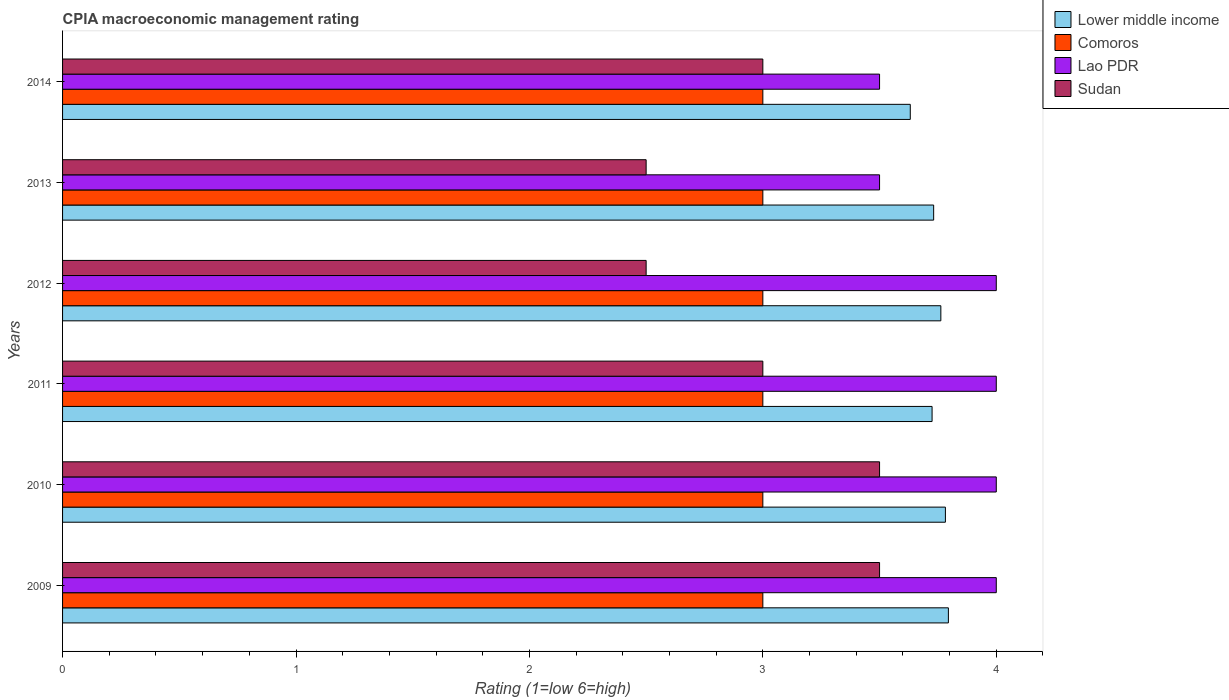How many groups of bars are there?
Make the answer very short. 6. How many bars are there on the 2nd tick from the top?
Keep it short and to the point. 4. How many bars are there on the 3rd tick from the bottom?
Ensure brevity in your answer.  4. What is the label of the 4th group of bars from the top?
Ensure brevity in your answer.  2011. What is the CPIA rating in Lower middle income in 2009?
Make the answer very short. 3.79. Across all years, what is the maximum CPIA rating in Lao PDR?
Offer a terse response. 4. Across all years, what is the minimum CPIA rating in Lower middle income?
Offer a very short reply. 3.63. In which year was the CPIA rating in Lao PDR minimum?
Keep it short and to the point. 2013. What is the difference between the CPIA rating in Lao PDR in 2012 and that in 2013?
Keep it short and to the point. 0.5. What is the difference between the CPIA rating in Comoros in 2013 and the CPIA rating in Lower middle income in 2012?
Your answer should be very brief. -0.76. What is the average CPIA rating in Lao PDR per year?
Give a very brief answer. 3.83. In the year 2013, what is the difference between the CPIA rating in Lao PDR and CPIA rating in Lower middle income?
Your answer should be very brief. -0.23. What is the ratio of the CPIA rating in Lao PDR in 2012 to that in 2014?
Keep it short and to the point. 1.14. Is the CPIA rating in Lower middle income in 2010 less than that in 2013?
Offer a very short reply. No. Is the difference between the CPIA rating in Lao PDR in 2009 and 2012 greater than the difference between the CPIA rating in Lower middle income in 2009 and 2012?
Make the answer very short. No. What is the difference between the highest and the second highest CPIA rating in Lower middle income?
Ensure brevity in your answer.  0.01. In how many years, is the CPIA rating in Sudan greater than the average CPIA rating in Sudan taken over all years?
Give a very brief answer. 2. What does the 1st bar from the top in 2013 represents?
Your response must be concise. Sudan. What does the 1st bar from the bottom in 2011 represents?
Ensure brevity in your answer.  Lower middle income. How many years are there in the graph?
Your answer should be very brief. 6. What is the difference between two consecutive major ticks on the X-axis?
Provide a succinct answer. 1. Are the values on the major ticks of X-axis written in scientific E-notation?
Keep it short and to the point. No. How many legend labels are there?
Your answer should be compact. 4. How are the legend labels stacked?
Offer a terse response. Vertical. What is the title of the graph?
Provide a succinct answer. CPIA macroeconomic management rating. Does "Trinidad and Tobago" appear as one of the legend labels in the graph?
Provide a succinct answer. No. What is the label or title of the X-axis?
Make the answer very short. Rating (1=low 6=high). What is the Rating (1=low 6=high) in Lower middle income in 2009?
Keep it short and to the point. 3.79. What is the Rating (1=low 6=high) in Comoros in 2009?
Make the answer very short. 3. What is the Rating (1=low 6=high) of Lao PDR in 2009?
Your answer should be compact. 4. What is the Rating (1=low 6=high) of Sudan in 2009?
Keep it short and to the point. 3.5. What is the Rating (1=low 6=high) of Lower middle income in 2010?
Offer a terse response. 3.78. What is the Rating (1=low 6=high) in Comoros in 2010?
Offer a very short reply. 3. What is the Rating (1=low 6=high) in Lao PDR in 2010?
Ensure brevity in your answer.  4. What is the Rating (1=low 6=high) in Sudan in 2010?
Offer a terse response. 3.5. What is the Rating (1=low 6=high) of Lower middle income in 2011?
Your response must be concise. 3.73. What is the Rating (1=low 6=high) of Comoros in 2011?
Your answer should be compact. 3. What is the Rating (1=low 6=high) in Lao PDR in 2011?
Keep it short and to the point. 4. What is the Rating (1=low 6=high) of Lower middle income in 2012?
Offer a very short reply. 3.76. What is the Rating (1=low 6=high) in Sudan in 2012?
Keep it short and to the point. 2.5. What is the Rating (1=low 6=high) in Lower middle income in 2013?
Your answer should be compact. 3.73. What is the Rating (1=low 6=high) in Comoros in 2013?
Provide a short and direct response. 3. What is the Rating (1=low 6=high) of Sudan in 2013?
Offer a very short reply. 2.5. What is the Rating (1=low 6=high) in Lower middle income in 2014?
Your answer should be very brief. 3.63. What is the Rating (1=low 6=high) in Lao PDR in 2014?
Offer a terse response. 3.5. What is the Rating (1=low 6=high) of Sudan in 2014?
Provide a short and direct response. 3. Across all years, what is the maximum Rating (1=low 6=high) of Lower middle income?
Offer a very short reply. 3.79. Across all years, what is the maximum Rating (1=low 6=high) in Comoros?
Your answer should be compact. 3. Across all years, what is the maximum Rating (1=low 6=high) in Lao PDR?
Your answer should be very brief. 4. Across all years, what is the maximum Rating (1=low 6=high) in Sudan?
Ensure brevity in your answer.  3.5. Across all years, what is the minimum Rating (1=low 6=high) in Lower middle income?
Your answer should be very brief. 3.63. Across all years, what is the minimum Rating (1=low 6=high) in Comoros?
Provide a succinct answer. 3. Across all years, what is the minimum Rating (1=low 6=high) in Lao PDR?
Provide a short and direct response. 3.5. Across all years, what is the minimum Rating (1=low 6=high) in Sudan?
Your response must be concise. 2.5. What is the total Rating (1=low 6=high) in Lower middle income in the graph?
Make the answer very short. 22.43. What is the total Rating (1=low 6=high) of Comoros in the graph?
Make the answer very short. 18. What is the total Rating (1=low 6=high) in Sudan in the graph?
Your response must be concise. 18. What is the difference between the Rating (1=low 6=high) of Lower middle income in 2009 and that in 2010?
Offer a very short reply. 0.01. What is the difference between the Rating (1=low 6=high) of Lao PDR in 2009 and that in 2010?
Your response must be concise. 0. What is the difference between the Rating (1=low 6=high) of Sudan in 2009 and that in 2010?
Provide a succinct answer. 0. What is the difference between the Rating (1=low 6=high) of Lower middle income in 2009 and that in 2011?
Provide a short and direct response. 0.07. What is the difference between the Rating (1=low 6=high) of Lao PDR in 2009 and that in 2011?
Keep it short and to the point. 0. What is the difference between the Rating (1=low 6=high) of Sudan in 2009 and that in 2011?
Make the answer very short. 0.5. What is the difference between the Rating (1=low 6=high) in Lower middle income in 2009 and that in 2012?
Give a very brief answer. 0.03. What is the difference between the Rating (1=low 6=high) of Lao PDR in 2009 and that in 2012?
Keep it short and to the point. 0. What is the difference between the Rating (1=low 6=high) in Sudan in 2009 and that in 2012?
Give a very brief answer. 1. What is the difference between the Rating (1=low 6=high) in Lower middle income in 2009 and that in 2013?
Your answer should be compact. 0.06. What is the difference between the Rating (1=low 6=high) in Comoros in 2009 and that in 2013?
Your answer should be compact. 0. What is the difference between the Rating (1=low 6=high) in Lao PDR in 2009 and that in 2013?
Ensure brevity in your answer.  0.5. What is the difference between the Rating (1=low 6=high) in Lower middle income in 2009 and that in 2014?
Provide a succinct answer. 0.16. What is the difference between the Rating (1=low 6=high) of Lao PDR in 2009 and that in 2014?
Ensure brevity in your answer.  0.5. What is the difference between the Rating (1=low 6=high) in Sudan in 2009 and that in 2014?
Provide a succinct answer. 0.5. What is the difference between the Rating (1=low 6=high) of Lower middle income in 2010 and that in 2011?
Offer a very short reply. 0.06. What is the difference between the Rating (1=low 6=high) of Comoros in 2010 and that in 2011?
Offer a terse response. 0. What is the difference between the Rating (1=low 6=high) in Lao PDR in 2010 and that in 2011?
Make the answer very short. 0. What is the difference between the Rating (1=low 6=high) of Sudan in 2010 and that in 2011?
Give a very brief answer. 0.5. What is the difference between the Rating (1=low 6=high) in Lower middle income in 2010 and that in 2012?
Your answer should be very brief. 0.02. What is the difference between the Rating (1=low 6=high) of Comoros in 2010 and that in 2012?
Your answer should be compact. 0. What is the difference between the Rating (1=low 6=high) in Lower middle income in 2010 and that in 2013?
Give a very brief answer. 0.05. What is the difference between the Rating (1=low 6=high) of Lao PDR in 2010 and that in 2013?
Keep it short and to the point. 0.5. What is the difference between the Rating (1=low 6=high) of Sudan in 2010 and that in 2013?
Provide a short and direct response. 1. What is the difference between the Rating (1=low 6=high) in Lower middle income in 2010 and that in 2014?
Make the answer very short. 0.15. What is the difference between the Rating (1=low 6=high) of Lao PDR in 2010 and that in 2014?
Make the answer very short. 0.5. What is the difference between the Rating (1=low 6=high) in Lower middle income in 2011 and that in 2012?
Provide a succinct answer. -0.04. What is the difference between the Rating (1=low 6=high) of Lower middle income in 2011 and that in 2013?
Keep it short and to the point. -0.01. What is the difference between the Rating (1=low 6=high) in Comoros in 2011 and that in 2013?
Provide a short and direct response. 0. What is the difference between the Rating (1=low 6=high) in Lao PDR in 2011 and that in 2013?
Provide a succinct answer. 0.5. What is the difference between the Rating (1=low 6=high) in Lower middle income in 2011 and that in 2014?
Offer a terse response. 0.09. What is the difference between the Rating (1=low 6=high) of Comoros in 2011 and that in 2014?
Your answer should be compact. 0. What is the difference between the Rating (1=low 6=high) in Lao PDR in 2011 and that in 2014?
Keep it short and to the point. 0.5. What is the difference between the Rating (1=low 6=high) of Sudan in 2011 and that in 2014?
Keep it short and to the point. 0. What is the difference between the Rating (1=low 6=high) in Lower middle income in 2012 and that in 2013?
Provide a succinct answer. 0.03. What is the difference between the Rating (1=low 6=high) in Comoros in 2012 and that in 2013?
Your answer should be very brief. 0. What is the difference between the Rating (1=low 6=high) of Sudan in 2012 and that in 2013?
Provide a succinct answer. 0. What is the difference between the Rating (1=low 6=high) in Lower middle income in 2012 and that in 2014?
Offer a very short reply. 0.13. What is the difference between the Rating (1=low 6=high) of Comoros in 2012 and that in 2014?
Make the answer very short. 0. What is the difference between the Rating (1=low 6=high) of Sudan in 2012 and that in 2014?
Offer a terse response. -0.5. What is the difference between the Rating (1=low 6=high) in Lower middle income in 2013 and that in 2014?
Your response must be concise. 0.1. What is the difference between the Rating (1=low 6=high) of Sudan in 2013 and that in 2014?
Your response must be concise. -0.5. What is the difference between the Rating (1=low 6=high) in Lower middle income in 2009 and the Rating (1=low 6=high) in Comoros in 2010?
Offer a very short reply. 0.79. What is the difference between the Rating (1=low 6=high) of Lower middle income in 2009 and the Rating (1=low 6=high) of Lao PDR in 2010?
Your answer should be very brief. -0.21. What is the difference between the Rating (1=low 6=high) in Lower middle income in 2009 and the Rating (1=low 6=high) in Sudan in 2010?
Offer a very short reply. 0.29. What is the difference between the Rating (1=low 6=high) in Comoros in 2009 and the Rating (1=low 6=high) in Lao PDR in 2010?
Your answer should be compact. -1. What is the difference between the Rating (1=low 6=high) in Comoros in 2009 and the Rating (1=low 6=high) in Sudan in 2010?
Your response must be concise. -0.5. What is the difference between the Rating (1=low 6=high) of Lower middle income in 2009 and the Rating (1=low 6=high) of Comoros in 2011?
Your response must be concise. 0.79. What is the difference between the Rating (1=low 6=high) in Lower middle income in 2009 and the Rating (1=low 6=high) in Lao PDR in 2011?
Provide a short and direct response. -0.21. What is the difference between the Rating (1=low 6=high) in Lower middle income in 2009 and the Rating (1=low 6=high) in Sudan in 2011?
Your response must be concise. 0.79. What is the difference between the Rating (1=low 6=high) of Comoros in 2009 and the Rating (1=low 6=high) of Lao PDR in 2011?
Offer a very short reply. -1. What is the difference between the Rating (1=low 6=high) in Comoros in 2009 and the Rating (1=low 6=high) in Sudan in 2011?
Offer a terse response. 0. What is the difference between the Rating (1=low 6=high) of Lao PDR in 2009 and the Rating (1=low 6=high) of Sudan in 2011?
Provide a succinct answer. 1. What is the difference between the Rating (1=low 6=high) of Lower middle income in 2009 and the Rating (1=low 6=high) of Comoros in 2012?
Make the answer very short. 0.79. What is the difference between the Rating (1=low 6=high) in Lower middle income in 2009 and the Rating (1=low 6=high) in Lao PDR in 2012?
Offer a very short reply. -0.21. What is the difference between the Rating (1=low 6=high) in Lower middle income in 2009 and the Rating (1=low 6=high) in Sudan in 2012?
Your response must be concise. 1.29. What is the difference between the Rating (1=low 6=high) of Comoros in 2009 and the Rating (1=low 6=high) of Lao PDR in 2012?
Make the answer very short. -1. What is the difference between the Rating (1=low 6=high) of Comoros in 2009 and the Rating (1=low 6=high) of Sudan in 2012?
Give a very brief answer. 0.5. What is the difference between the Rating (1=low 6=high) of Lao PDR in 2009 and the Rating (1=low 6=high) of Sudan in 2012?
Keep it short and to the point. 1.5. What is the difference between the Rating (1=low 6=high) of Lower middle income in 2009 and the Rating (1=low 6=high) of Comoros in 2013?
Provide a succinct answer. 0.79. What is the difference between the Rating (1=low 6=high) in Lower middle income in 2009 and the Rating (1=low 6=high) in Lao PDR in 2013?
Offer a terse response. 0.29. What is the difference between the Rating (1=low 6=high) in Lower middle income in 2009 and the Rating (1=low 6=high) in Sudan in 2013?
Give a very brief answer. 1.29. What is the difference between the Rating (1=low 6=high) in Lower middle income in 2009 and the Rating (1=low 6=high) in Comoros in 2014?
Give a very brief answer. 0.79. What is the difference between the Rating (1=low 6=high) of Lower middle income in 2009 and the Rating (1=low 6=high) of Lao PDR in 2014?
Provide a short and direct response. 0.29. What is the difference between the Rating (1=low 6=high) of Lower middle income in 2009 and the Rating (1=low 6=high) of Sudan in 2014?
Your response must be concise. 0.79. What is the difference between the Rating (1=low 6=high) in Comoros in 2009 and the Rating (1=low 6=high) in Sudan in 2014?
Your response must be concise. 0. What is the difference between the Rating (1=low 6=high) of Lower middle income in 2010 and the Rating (1=low 6=high) of Comoros in 2011?
Offer a terse response. 0.78. What is the difference between the Rating (1=low 6=high) in Lower middle income in 2010 and the Rating (1=low 6=high) in Lao PDR in 2011?
Offer a terse response. -0.22. What is the difference between the Rating (1=low 6=high) in Lower middle income in 2010 and the Rating (1=low 6=high) in Sudan in 2011?
Your answer should be very brief. 0.78. What is the difference between the Rating (1=low 6=high) of Comoros in 2010 and the Rating (1=low 6=high) of Lao PDR in 2011?
Your answer should be very brief. -1. What is the difference between the Rating (1=low 6=high) in Lower middle income in 2010 and the Rating (1=low 6=high) in Comoros in 2012?
Provide a short and direct response. 0.78. What is the difference between the Rating (1=low 6=high) of Lower middle income in 2010 and the Rating (1=low 6=high) of Lao PDR in 2012?
Your answer should be compact. -0.22. What is the difference between the Rating (1=low 6=high) in Lower middle income in 2010 and the Rating (1=low 6=high) in Sudan in 2012?
Provide a short and direct response. 1.28. What is the difference between the Rating (1=low 6=high) of Comoros in 2010 and the Rating (1=low 6=high) of Lao PDR in 2012?
Your response must be concise. -1. What is the difference between the Rating (1=low 6=high) of Lower middle income in 2010 and the Rating (1=low 6=high) of Comoros in 2013?
Keep it short and to the point. 0.78. What is the difference between the Rating (1=low 6=high) in Lower middle income in 2010 and the Rating (1=low 6=high) in Lao PDR in 2013?
Make the answer very short. 0.28. What is the difference between the Rating (1=low 6=high) in Lower middle income in 2010 and the Rating (1=low 6=high) in Sudan in 2013?
Offer a very short reply. 1.28. What is the difference between the Rating (1=low 6=high) in Lao PDR in 2010 and the Rating (1=low 6=high) in Sudan in 2013?
Offer a terse response. 1.5. What is the difference between the Rating (1=low 6=high) in Lower middle income in 2010 and the Rating (1=low 6=high) in Comoros in 2014?
Make the answer very short. 0.78. What is the difference between the Rating (1=low 6=high) of Lower middle income in 2010 and the Rating (1=low 6=high) of Lao PDR in 2014?
Your response must be concise. 0.28. What is the difference between the Rating (1=low 6=high) in Lower middle income in 2010 and the Rating (1=low 6=high) in Sudan in 2014?
Offer a very short reply. 0.78. What is the difference between the Rating (1=low 6=high) in Lao PDR in 2010 and the Rating (1=low 6=high) in Sudan in 2014?
Your answer should be compact. 1. What is the difference between the Rating (1=low 6=high) in Lower middle income in 2011 and the Rating (1=low 6=high) in Comoros in 2012?
Offer a very short reply. 0.72. What is the difference between the Rating (1=low 6=high) of Lower middle income in 2011 and the Rating (1=low 6=high) of Lao PDR in 2012?
Offer a terse response. -0.28. What is the difference between the Rating (1=low 6=high) of Lower middle income in 2011 and the Rating (1=low 6=high) of Sudan in 2012?
Offer a very short reply. 1.23. What is the difference between the Rating (1=low 6=high) of Comoros in 2011 and the Rating (1=low 6=high) of Lao PDR in 2012?
Your answer should be compact. -1. What is the difference between the Rating (1=low 6=high) of Comoros in 2011 and the Rating (1=low 6=high) of Sudan in 2012?
Provide a succinct answer. 0.5. What is the difference between the Rating (1=low 6=high) of Lower middle income in 2011 and the Rating (1=low 6=high) of Comoros in 2013?
Your answer should be compact. 0.72. What is the difference between the Rating (1=low 6=high) in Lower middle income in 2011 and the Rating (1=low 6=high) in Lao PDR in 2013?
Your answer should be very brief. 0.23. What is the difference between the Rating (1=low 6=high) of Lower middle income in 2011 and the Rating (1=low 6=high) of Sudan in 2013?
Offer a terse response. 1.23. What is the difference between the Rating (1=low 6=high) of Comoros in 2011 and the Rating (1=low 6=high) of Lao PDR in 2013?
Offer a terse response. -0.5. What is the difference between the Rating (1=low 6=high) in Comoros in 2011 and the Rating (1=low 6=high) in Sudan in 2013?
Give a very brief answer. 0.5. What is the difference between the Rating (1=low 6=high) in Lao PDR in 2011 and the Rating (1=low 6=high) in Sudan in 2013?
Give a very brief answer. 1.5. What is the difference between the Rating (1=low 6=high) of Lower middle income in 2011 and the Rating (1=low 6=high) of Comoros in 2014?
Ensure brevity in your answer.  0.72. What is the difference between the Rating (1=low 6=high) in Lower middle income in 2011 and the Rating (1=low 6=high) in Lao PDR in 2014?
Make the answer very short. 0.23. What is the difference between the Rating (1=low 6=high) of Lower middle income in 2011 and the Rating (1=low 6=high) of Sudan in 2014?
Make the answer very short. 0.72. What is the difference between the Rating (1=low 6=high) in Comoros in 2011 and the Rating (1=low 6=high) in Sudan in 2014?
Offer a very short reply. 0. What is the difference between the Rating (1=low 6=high) of Lao PDR in 2011 and the Rating (1=low 6=high) of Sudan in 2014?
Provide a short and direct response. 1. What is the difference between the Rating (1=low 6=high) of Lower middle income in 2012 and the Rating (1=low 6=high) of Comoros in 2013?
Make the answer very short. 0.76. What is the difference between the Rating (1=low 6=high) of Lower middle income in 2012 and the Rating (1=low 6=high) of Lao PDR in 2013?
Offer a terse response. 0.26. What is the difference between the Rating (1=low 6=high) of Lower middle income in 2012 and the Rating (1=low 6=high) of Sudan in 2013?
Provide a short and direct response. 1.26. What is the difference between the Rating (1=low 6=high) in Lower middle income in 2012 and the Rating (1=low 6=high) in Comoros in 2014?
Keep it short and to the point. 0.76. What is the difference between the Rating (1=low 6=high) in Lower middle income in 2012 and the Rating (1=low 6=high) in Lao PDR in 2014?
Give a very brief answer. 0.26. What is the difference between the Rating (1=low 6=high) in Lower middle income in 2012 and the Rating (1=low 6=high) in Sudan in 2014?
Give a very brief answer. 0.76. What is the difference between the Rating (1=low 6=high) in Comoros in 2012 and the Rating (1=low 6=high) in Lao PDR in 2014?
Your answer should be compact. -0.5. What is the difference between the Rating (1=low 6=high) in Comoros in 2012 and the Rating (1=low 6=high) in Sudan in 2014?
Provide a short and direct response. 0. What is the difference between the Rating (1=low 6=high) of Lao PDR in 2012 and the Rating (1=low 6=high) of Sudan in 2014?
Give a very brief answer. 1. What is the difference between the Rating (1=low 6=high) in Lower middle income in 2013 and the Rating (1=low 6=high) in Comoros in 2014?
Offer a very short reply. 0.73. What is the difference between the Rating (1=low 6=high) in Lower middle income in 2013 and the Rating (1=low 6=high) in Lao PDR in 2014?
Make the answer very short. 0.23. What is the difference between the Rating (1=low 6=high) of Lower middle income in 2013 and the Rating (1=low 6=high) of Sudan in 2014?
Offer a terse response. 0.73. What is the difference between the Rating (1=low 6=high) in Lao PDR in 2013 and the Rating (1=low 6=high) in Sudan in 2014?
Provide a succinct answer. 0.5. What is the average Rating (1=low 6=high) of Lower middle income per year?
Provide a succinct answer. 3.74. What is the average Rating (1=low 6=high) in Lao PDR per year?
Your answer should be very brief. 3.83. In the year 2009, what is the difference between the Rating (1=low 6=high) in Lower middle income and Rating (1=low 6=high) in Comoros?
Offer a terse response. 0.79. In the year 2009, what is the difference between the Rating (1=low 6=high) in Lower middle income and Rating (1=low 6=high) in Lao PDR?
Keep it short and to the point. -0.21. In the year 2009, what is the difference between the Rating (1=low 6=high) of Lower middle income and Rating (1=low 6=high) of Sudan?
Ensure brevity in your answer.  0.29. In the year 2009, what is the difference between the Rating (1=low 6=high) in Comoros and Rating (1=low 6=high) in Lao PDR?
Give a very brief answer. -1. In the year 2009, what is the difference between the Rating (1=low 6=high) of Comoros and Rating (1=low 6=high) of Sudan?
Your answer should be very brief. -0.5. In the year 2009, what is the difference between the Rating (1=low 6=high) in Lao PDR and Rating (1=low 6=high) in Sudan?
Make the answer very short. 0.5. In the year 2010, what is the difference between the Rating (1=low 6=high) in Lower middle income and Rating (1=low 6=high) in Comoros?
Provide a succinct answer. 0.78. In the year 2010, what is the difference between the Rating (1=low 6=high) in Lower middle income and Rating (1=low 6=high) in Lao PDR?
Your response must be concise. -0.22. In the year 2010, what is the difference between the Rating (1=low 6=high) in Lower middle income and Rating (1=low 6=high) in Sudan?
Give a very brief answer. 0.28. In the year 2010, what is the difference between the Rating (1=low 6=high) of Comoros and Rating (1=low 6=high) of Lao PDR?
Your answer should be very brief. -1. In the year 2010, what is the difference between the Rating (1=low 6=high) in Lao PDR and Rating (1=low 6=high) in Sudan?
Ensure brevity in your answer.  0.5. In the year 2011, what is the difference between the Rating (1=low 6=high) of Lower middle income and Rating (1=low 6=high) of Comoros?
Offer a terse response. 0.72. In the year 2011, what is the difference between the Rating (1=low 6=high) in Lower middle income and Rating (1=low 6=high) in Lao PDR?
Make the answer very short. -0.28. In the year 2011, what is the difference between the Rating (1=low 6=high) of Lower middle income and Rating (1=low 6=high) of Sudan?
Give a very brief answer. 0.72. In the year 2011, what is the difference between the Rating (1=low 6=high) in Comoros and Rating (1=low 6=high) in Lao PDR?
Ensure brevity in your answer.  -1. In the year 2011, what is the difference between the Rating (1=low 6=high) in Lao PDR and Rating (1=low 6=high) in Sudan?
Your answer should be compact. 1. In the year 2012, what is the difference between the Rating (1=low 6=high) in Lower middle income and Rating (1=low 6=high) in Comoros?
Provide a short and direct response. 0.76. In the year 2012, what is the difference between the Rating (1=low 6=high) of Lower middle income and Rating (1=low 6=high) of Lao PDR?
Offer a very short reply. -0.24. In the year 2012, what is the difference between the Rating (1=low 6=high) in Lower middle income and Rating (1=low 6=high) in Sudan?
Offer a very short reply. 1.26. In the year 2012, what is the difference between the Rating (1=low 6=high) of Comoros and Rating (1=low 6=high) of Sudan?
Ensure brevity in your answer.  0.5. In the year 2013, what is the difference between the Rating (1=low 6=high) in Lower middle income and Rating (1=low 6=high) in Comoros?
Provide a succinct answer. 0.73. In the year 2013, what is the difference between the Rating (1=low 6=high) in Lower middle income and Rating (1=low 6=high) in Lao PDR?
Ensure brevity in your answer.  0.23. In the year 2013, what is the difference between the Rating (1=low 6=high) of Lower middle income and Rating (1=low 6=high) of Sudan?
Keep it short and to the point. 1.23. In the year 2013, what is the difference between the Rating (1=low 6=high) in Comoros and Rating (1=low 6=high) in Lao PDR?
Offer a terse response. -0.5. In the year 2013, what is the difference between the Rating (1=low 6=high) of Lao PDR and Rating (1=low 6=high) of Sudan?
Provide a succinct answer. 1. In the year 2014, what is the difference between the Rating (1=low 6=high) in Lower middle income and Rating (1=low 6=high) in Comoros?
Offer a terse response. 0.63. In the year 2014, what is the difference between the Rating (1=low 6=high) in Lower middle income and Rating (1=low 6=high) in Lao PDR?
Give a very brief answer. 0.13. In the year 2014, what is the difference between the Rating (1=low 6=high) in Lower middle income and Rating (1=low 6=high) in Sudan?
Offer a terse response. 0.63. In the year 2014, what is the difference between the Rating (1=low 6=high) of Comoros and Rating (1=low 6=high) of Lao PDR?
Give a very brief answer. -0.5. What is the ratio of the Rating (1=low 6=high) in Lower middle income in 2009 to that in 2010?
Your answer should be very brief. 1. What is the ratio of the Rating (1=low 6=high) of Comoros in 2009 to that in 2010?
Your answer should be very brief. 1. What is the ratio of the Rating (1=low 6=high) of Lao PDR in 2009 to that in 2010?
Keep it short and to the point. 1. What is the ratio of the Rating (1=low 6=high) of Lower middle income in 2009 to that in 2011?
Provide a short and direct response. 1.02. What is the ratio of the Rating (1=low 6=high) in Lower middle income in 2009 to that in 2012?
Your response must be concise. 1.01. What is the ratio of the Rating (1=low 6=high) in Comoros in 2009 to that in 2012?
Offer a very short reply. 1. What is the ratio of the Rating (1=low 6=high) of Sudan in 2009 to that in 2012?
Keep it short and to the point. 1.4. What is the ratio of the Rating (1=low 6=high) of Lower middle income in 2009 to that in 2013?
Keep it short and to the point. 1.02. What is the ratio of the Rating (1=low 6=high) of Lower middle income in 2009 to that in 2014?
Your response must be concise. 1.04. What is the ratio of the Rating (1=low 6=high) in Comoros in 2009 to that in 2014?
Offer a very short reply. 1. What is the ratio of the Rating (1=low 6=high) of Lao PDR in 2009 to that in 2014?
Offer a very short reply. 1.14. What is the ratio of the Rating (1=low 6=high) of Lower middle income in 2010 to that in 2011?
Your response must be concise. 1.02. What is the ratio of the Rating (1=low 6=high) of Comoros in 2010 to that in 2011?
Provide a succinct answer. 1. What is the ratio of the Rating (1=low 6=high) of Lao PDR in 2010 to that in 2011?
Keep it short and to the point. 1. What is the ratio of the Rating (1=low 6=high) of Sudan in 2010 to that in 2011?
Your response must be concise. 1.17. What is the ratio of the Rating (1=low 6=high) in Comoros in 2010 to that in 2012?
Ensure brevity in your answer.  1. What is the ratio of the Rating (1=low 6=high) of Lao PDR in 2010 to that in 2012?
Keep it short and to the point. 1. What is the ratio of the Rating (1=low 6=high) of Lower middle income in 2010 to that in 2013?
Your response must be concise. 1.01. What is the ratio of the Rating (1=low 6=high) in Comoros in 2010 to that in 2013?
Keep it short and to the point. 1. What is the ratio of the Rating (1=low 6=high) of Lao PDR in 2010 to that in 2013?
Keep it short and to the point. 1.14. What is the ratio of the Rating (1=low 6=high) of Sudan in 2010 to that in 2013?
Your response must be concise. 1.4. What is the ratio of the Rating (1=low 6=high) in Lower middle income in 2010 to that in 2014?
Your response must be concise. 1.04. What is the ratio of the Rating (1=low 6=high) of Comoros in 2010 to that in 2014?
Your answer should be compact. 1. What is the ratio of the Rating (1=low 6=high) of Lao PDR in 2010 to that in 2014?
Your answer should be compact. 1.14. What is the ratio of the Rating (1=low 6=high) in Comoros in 2011 to that in 2012?
Your answer should be compact. 1. What is the ratio of the Rating (1=low 6=high) of Sudan in 2011 to that in 2012?
Provide a succinct answer. 1.2. What is the ratio of the Rating (1=low 6=high) of Lower middle income in 2011 to that in 2013?
Ensure brevity in your answer.  1. What is the ratio of the Rating (1=low 6=high) of Comoros in 2011 to that in 2013?
Offer a very short reply. 1. What is the ratio of the Rating (1=low 6=high) of Lao PDR in 2011 to that in 2013?
Offer a terse response. 1.14. What is the ratio of the Rating (1=low 6=high) in Sudan in 2011 to that in 2013?
Provide a short and direct response. 1.2. What is the ratio of the Rating (1=low 6=high) of Lower middle income in 2011 to that in 2014?
Offer a very short reply. 1.03. What is the ratio of the Rating (1=low 6=high) in Comoros in 2011 to that in 2014?
Provide a succinct answer. 1. What is the ratio of the Rating (1=low 6=high) in Lao PDR in 2011 to that in 2014?
Provide a succinct answer. 1.14. What is the ratio of the Rating (1=low 6=high) in Lower middle income in 2012 to that in 2013?
Offer a very short reply. 1.01. What is the ratio of the Rating (1=low 6=high) of Sudan in 2012 to that in 2013?
Your answer should be compact. 1. What is the ratio of the Rating (1=low 6=high) of Lower middle income in 2012 to that in 2014?
Your answer should be very brief. 1.04. What is the ratio of the Rating (1=low 6=high) of Lower middle income in 2013 to that in 2014?
Give a very brief answer. 1.03. What is the ratio of the Rating (1=low 6=high) of Comoros in 2013 to that in 2014?
Your answer should be very brief. 1. What is the ratio of the Rating (1=low 6=high) of Sudan in 2013 to that in 2014?
Ensure brevity in your answer.  0.83. What is the difference between the highest and the second highest Rating (1=low 6=high) in Lower middle income?
Keep it short and to the point. 0.01. What is the difference between the highest and the second highest Rating (1=low 6=high) of Comoros?
Make the answer very short. 0. What is the difference between the highest and the second highest Rating (1=low 6=high) in Sudan?
Ensure brevity in your answer.  0. What is the difference between the highest and the lowest Rating (1=low 6=high) in Lower middle income?
Your answer should be very brief. 0.16. 